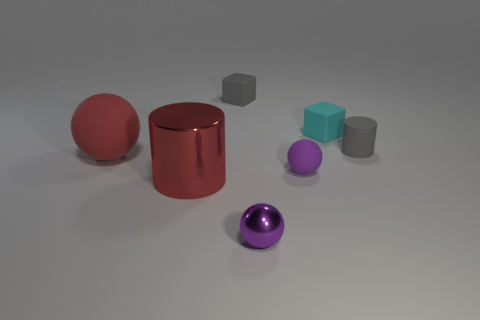Add 2 brown spheres. How many objects exist? 9 Subtract all cubes. How many objects are left? 5 Add 2 tiny cyan objects. How many tiny cyan objects are left? 3 Add 3 rubber cubes. How many rubber cubes exist? 5 Subtract 0 brown balls. How many objects are left? 7 Subtract all big red cylinders. Subtract all purple spheres. How many objects are left? 4 